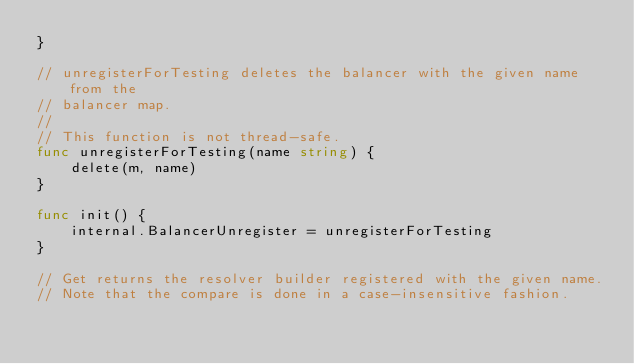<code> <loc_0><loc_0><loc_500><loc_500><_Go_>}

// unregisterForTesting deletes the balancer with the given name from the
// balancer map.
//
// This function is not thread-safe.
func unregisterForTesting(name string) {
	delete(m, name)
}

func init() {
	internal.BalancerUnregister = unregisterForTesting
}

// Get returns the resolver builder registered with the given name.
// Note that the compare is done in a case-insensitive fashion.</code> 